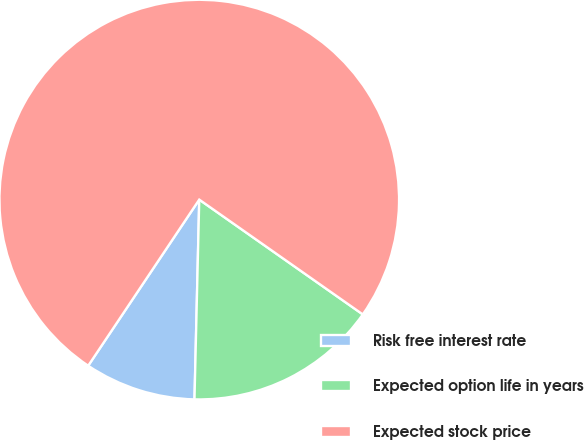Convert chart. <chart><loc_0><loc_0><loc_500><loc_500><pie_chart><fcel>Risk free interest rate<fcel>Expected option life in years<fcel>Expected stock price<nl><fcel>9.0%<fcel>15.64%<fcel>75.37%<nl></chart> 